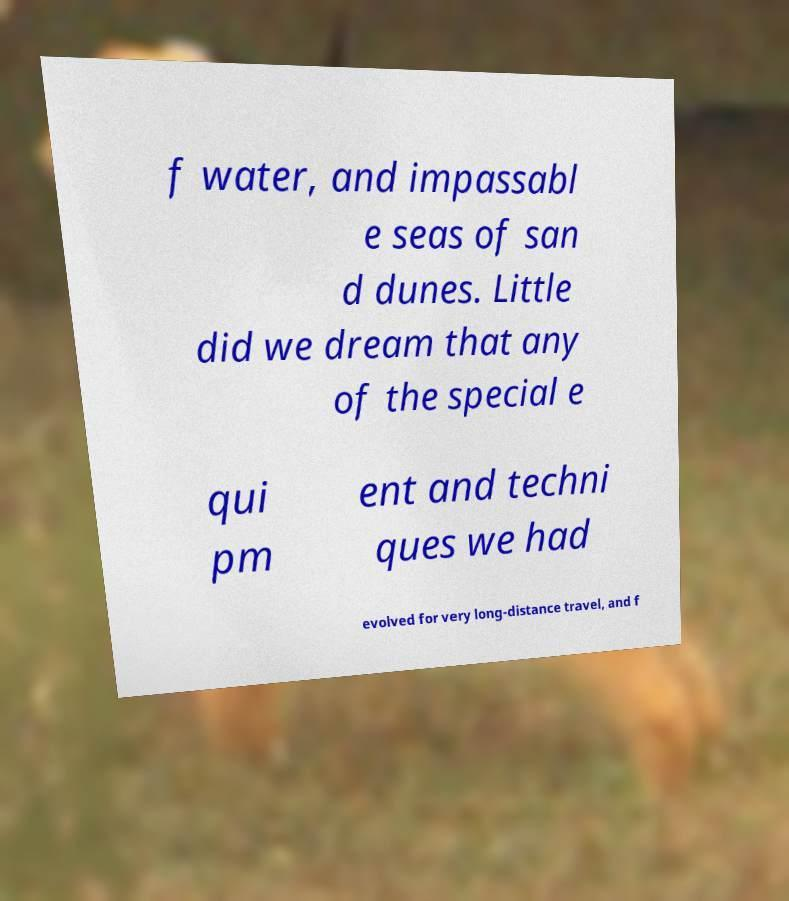Please read and relay the text visible in this image. What does it say? f water, and impassabl e seas of san d dunes. Little did we dream that any of the special e qui pm ent and techni ques we had evolved for very long-distance travel, and f 